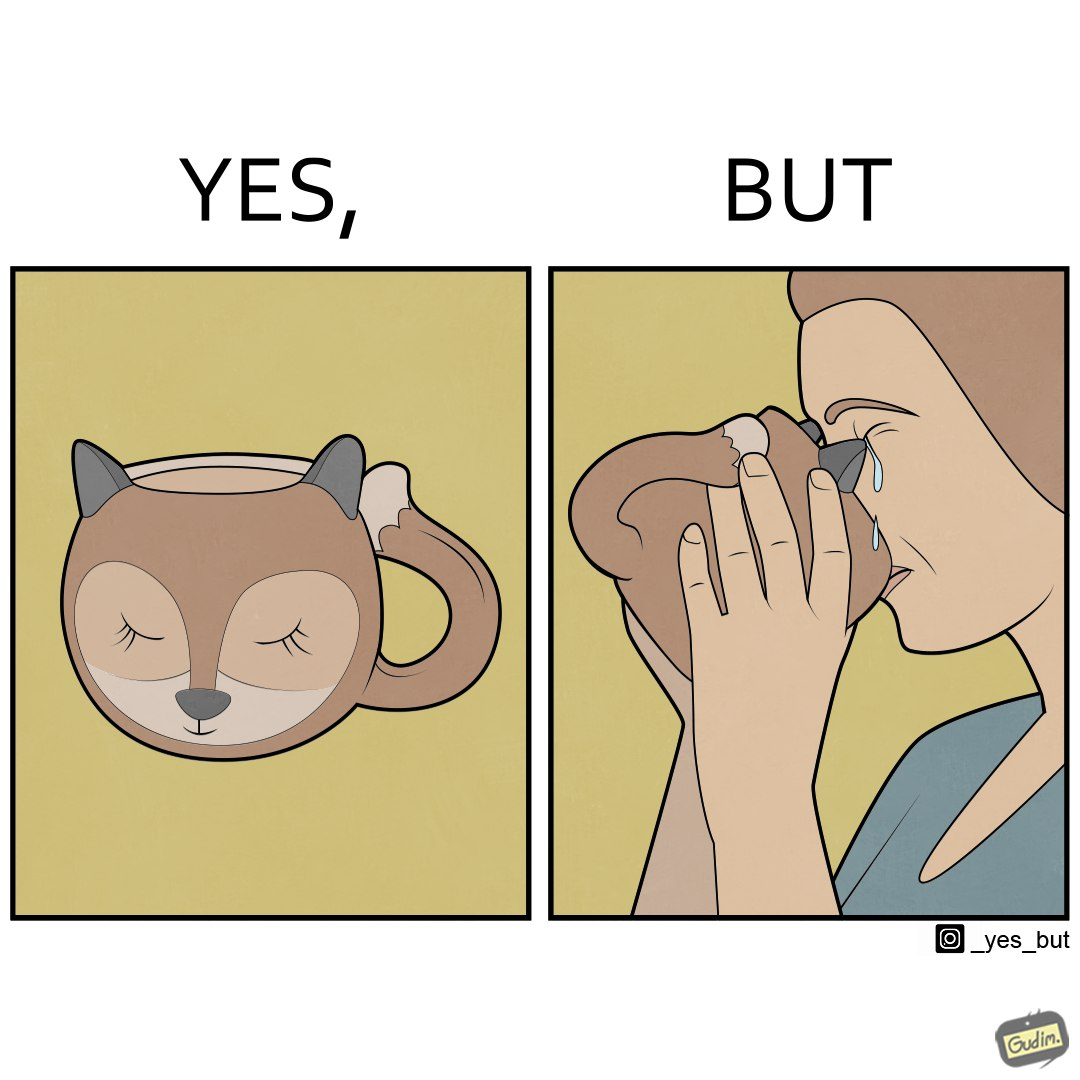What is shown in this image? The irony in the image is that the mug is supposedly cute and quirky but it is completely impractical as a mug as it will hurt its user. 